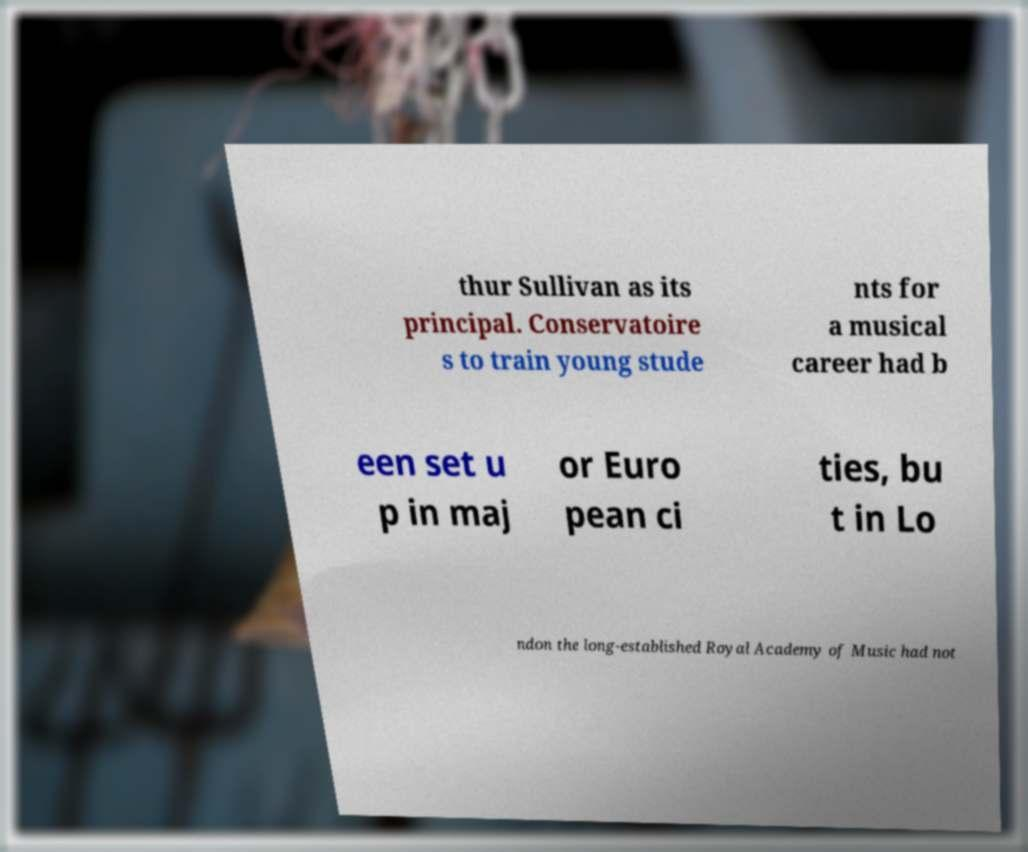Please identify and transcribe the text found in this image. thur Sullivan as its principal. Conservatoire s to train young stude nts for a musical career had b een set u p in maj or Euro pean ci ties, bu t in Lo ndon the long-established Royal Academy of Music had not 